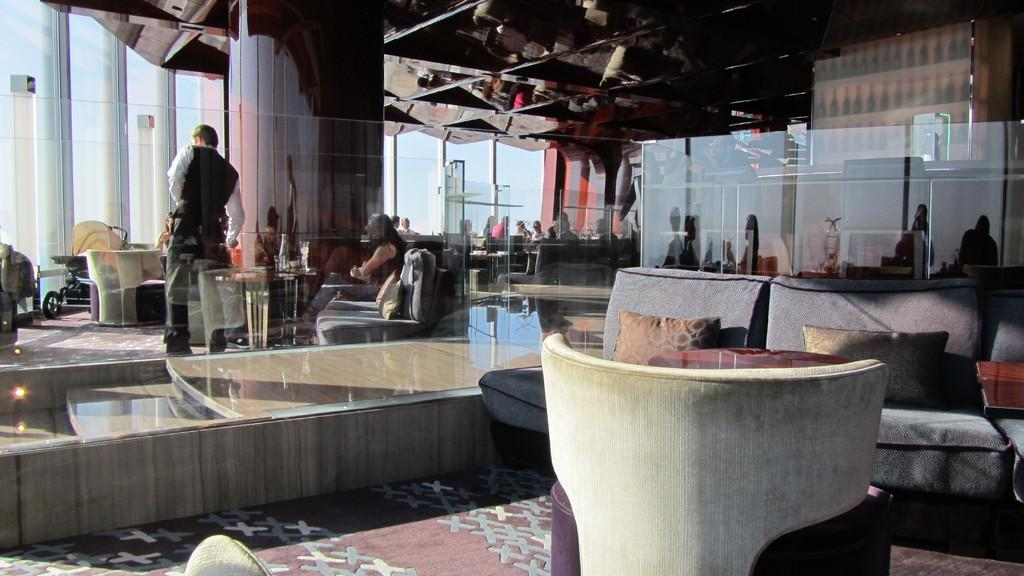What type of furniture is in the image? There is a couch in the image. What object is visible near the couch? There is a glass in the image. What are the people behind the glass doing? There are people sitting and at least one person standing behind the glass. What type of bait is being used by the uncle in the image? There is no uncle or bait present in the image. What point is the person standing behind the glass trying to make? There is no indication of a point being made by the person standing behind the glass in the image. 